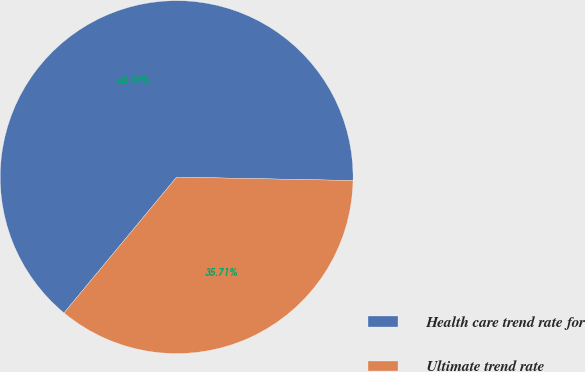Convert chart to OTSL. <chart><loc_0><loc_0><loc_500><loc_500><pie_chart><fcel>Health care trend rate for<fcel>Ultimate trend rate<nl><fcel>64.29%<fcel>35.71%<nl></chart> 